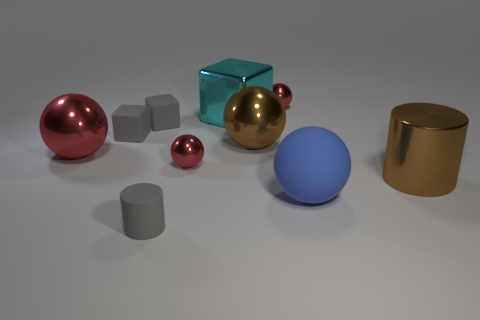Can you guess the purpose of the arrangement in this image? The arrangement of these objects seems to have an aesthetic purpose, likely to demonstrate the contrast in colors and textures, such as shiny versus matte surfaces. It could also be for a visual composition exercise or a computer graphics rendering test. Are there any patterns or themes in the arrangement that you notice? A noticeable theme is the contrast between the geometric shapes - spheres and cylinders versus cubes and the play on symmetry and asymmetry in the arrangement. Additionally, the image showcases a variety of colors and finishes, which could hint at a study of light interaction with different surfaces. 